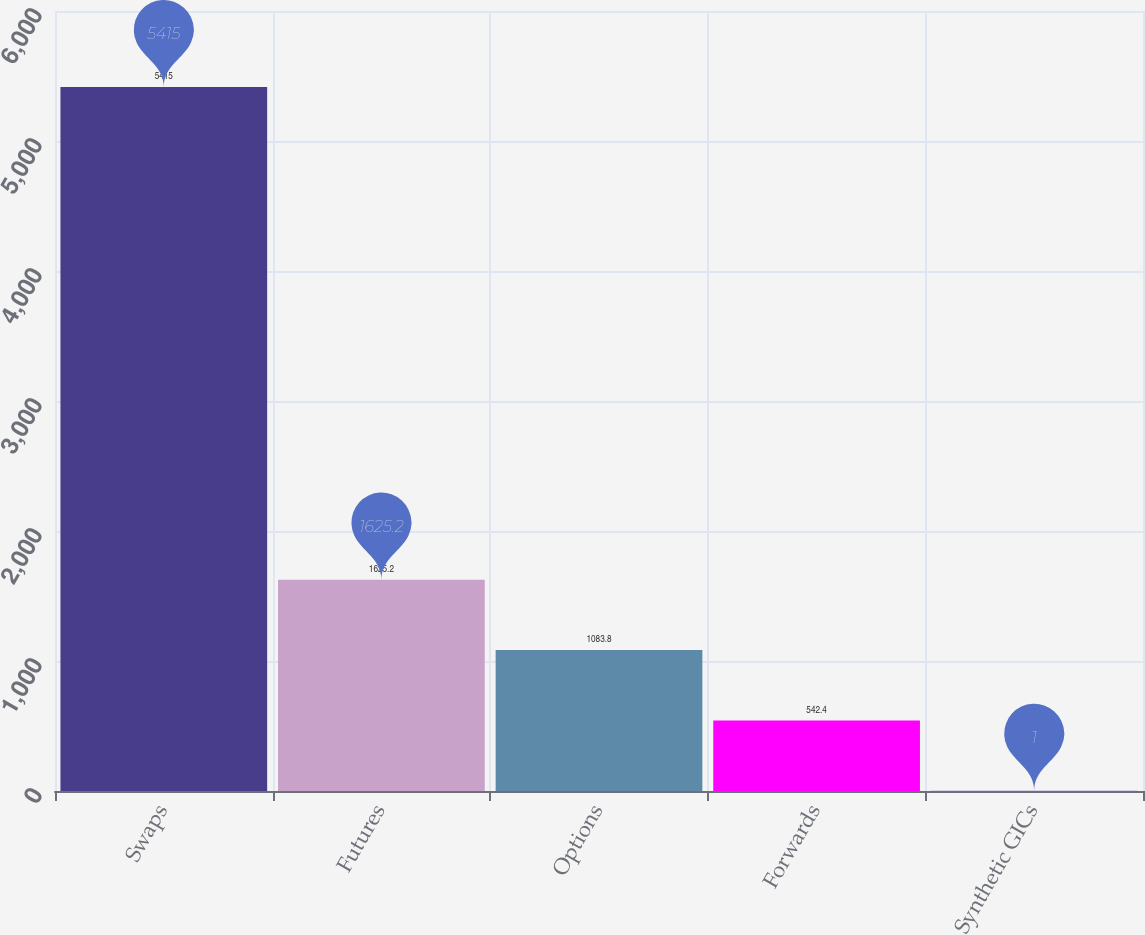Convert chart. <chart><loc_0><loc_0><loc_500><loc_500><bar_chart><fcel>Swaps<fcel>Futures<fcel>Options<fcel>Forwards<fcel>Synthetic GICs<nl><fcel>5415<fcel>1625.2<fcel>1083.8<fcel>542.4<fcel>1<nl></chart> 